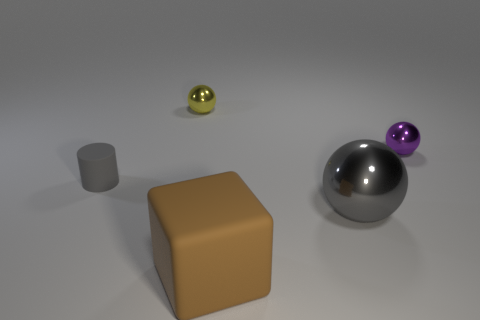What is the color of the other tiny ball that is made of the same material as the tiny purple ball?
Ensure brevity in your answer.  Yellow. What number of things are either large brown matte spheres or large objects?
Keep it short and to the point. 2. The other ball that is the same size as the yellow shiny sphere is what color?
Provide a succinct answer. Purple. How many things are brown rubber objects that are to the right of the tiny yellow ball or cyan cylinders?
Provide a succinct answer. 1. What number of other things are the same size as the gray rubber cylinder?
Give a very brief answer. 2. What is the size of the metallic ball that is in front of the small purple ball?
Provide a succinct answer. Large. The big thing that is the same material as the tiny purple object is what shape?
Give a very brief answer. Sphere. Are there any other things that are the same color as the large matte block?
Your response must be concise. No. What color is the object that is on the left side of the metal object behind the tiny purple ball?
Your response must be concise. Gray. What number of small objects are either metal objects or yellow shiny blocks?
Provide a succinct answer. 2. 